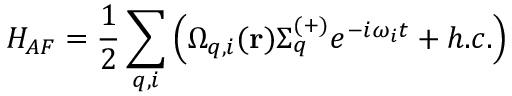<formula> <loc_0><loc_0><loc_500><loc_500>H _ { A F } = \frac { 1 } { 2 } \sum _ { q , i } \left ( \Omega _ { q , i } ( r ) \Sigma _ { q } ^ { ( + ) } e ^ { - i \omega _ { i } t } + h . c . \right )</formula> 